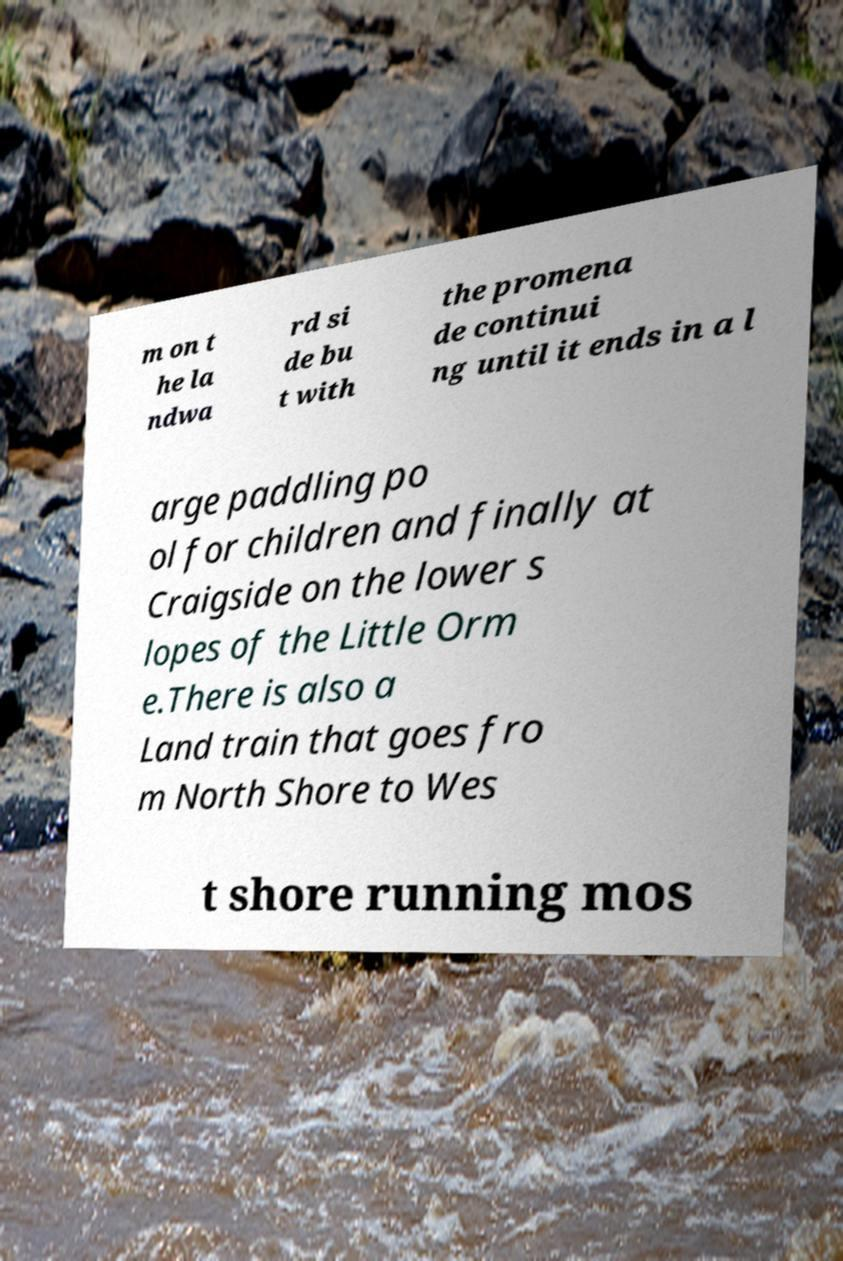Could you assist in decoding the text presented in this image and type it out clearly? m on t he la ndwa rd si de bu t with the promena de continui ng until it ends in a l arge paddling po ol for children and finally at Craigside on the lower s lopes of the Little Orm e.There is also a Land train that goes fro m North Shore to Wes t shore running mos 